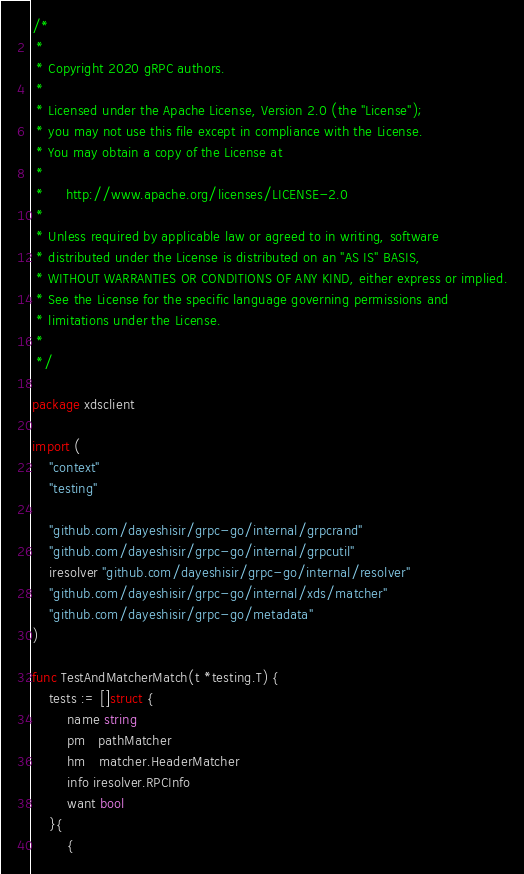<code> <loc_0><loc_0><loc_500><loc_500><_Go_>/*
 *
 * Copyright 2020 gRPC authors.
 *
 * Licensed under the Apache License, Version 2.0 (the "License");
 * you may not use this file except in compliance with the License.
 * You may obtain a copy of the License at
 *
 *     http://www.apache.org/licenses/LICENSE-2.0
 *
 * Unless required by applicable law or agreed to in writing, software
 * distributed under the License is distributed on an "AS IS" BASIS,
 * WITHOUT WARRANTIES OR CONDITIONS OF ANY KIND, either express or implied.
 * See the License for the specific language governing permissions and
 * limitations under the License.
 *
 */

package xdsclient

import (
	"context"
	"testing"

	"github.com/dayeshisir/grpc-go/internal/grpcrand"
	"github.com/dayeshisir/grpc-go/internal/grpcutil"
	iresolver "github.com/dayeshisir/grpc-go/internal/resolver"
	"github.com/dayeshisir/grpc-go/internal/xds/matcher"
	"github.com/dayeshisir/grpc-go/metadata"
)

func TestAndMatcherMatch(t *testing.T) {
	tests := []struct {
		name string
		pm   pathMatcher
		hm   matcher.HeaderMatcher
		info iresolver.RPCInfo
		want bool
	}{
		{</code> 